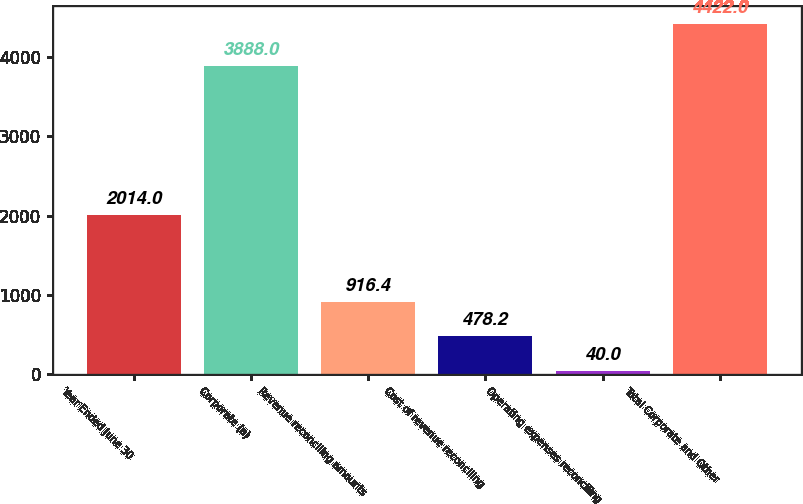Convert chart to OTSL. <chart><loc_0><loc_0><loc_500><loc_500><bar_chart><fcel>Year Ended June 30<fcel>Corporate (a)<fcel>Revenue reconciling amounts<fcel>Cost of revenue reconciling<fcel>Operating expenses reconciling<fcel>Total Corporate and Other<nl><fcel>2014<fcel>3888<fcel>916.4<fcel>478.2<fcel>40<fcel>4422<nl></chart> 